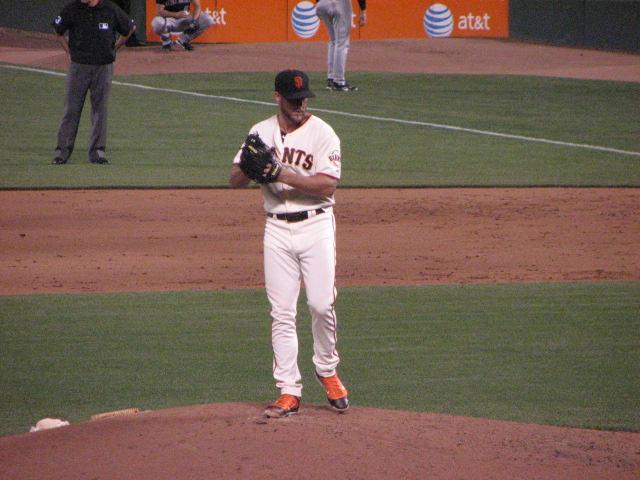What phone company is being advertised?
Short answer required. At&t. Does it look like this man only has one leg?
Give a very brief answer. No. What is the baseball player holding in his hands?
Concise answer only. Ball. What team is playing?
Answer briefly. Giants. Which team is playing?
Answer briefly. Giants. What color is the pitcher's hat?
Answer briefly. Black. In what city does these baseball players team reside?
Short answer required. New york. 